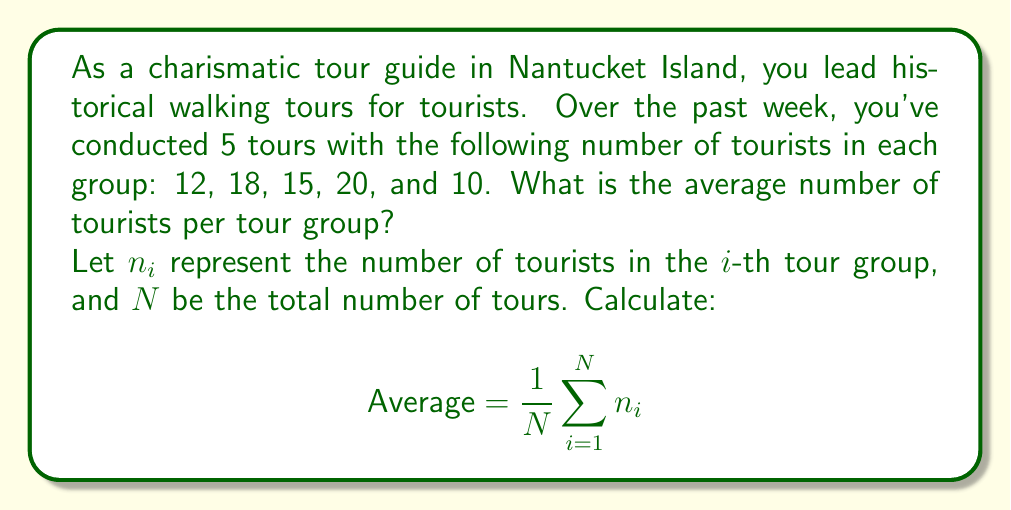Solve this math problem. To solve this problem, we need to:
1. Identify the given information:
   - Number of tours (N) = 5
   - Number of tourists in each group: 12, 18, 15, 20, and 10

2. Calculate the sum of all tourists:
   $$\sum_{i=1}^N n_i = 12 + 18 + 15 + 20 + 10 = 75$$

3. Apply the average formula:
   $$\text{Average} = \frac{1}{N} \sum_{i=1}^N n_i = \frac{1}{5} \cdot 75 = 15$$

Therefore, the average number of tourists per tour group is 15.
Answer: 15 tourists per tour group 